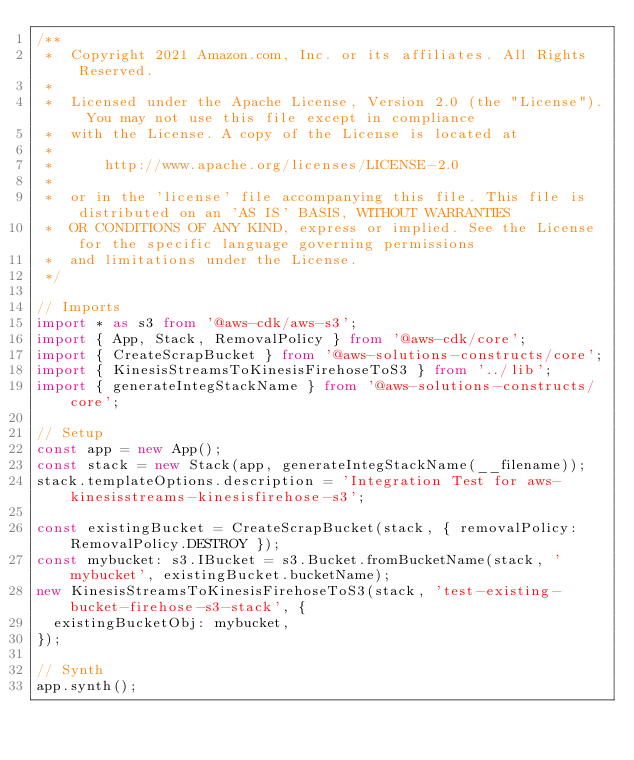<code> <loc_0><loc_0><loc_500><loc_500><_TypeScript_>/**
 *  Copyright 2021 Amazon.com, Inc. or its affiliates. All Rights Reserved.
 *
 *  Licensed under the Apache License, Version 2.0 (the "License"). You may not use this file except in compliance
 *  with the License. A copy of the License is located at
 *
 *      http://www.apache.org/licenses/LICENSE-2.0
 *
 *  or in the 'license' file accompanying this file. This file is distributed on an 'AS IS' BASIS, WITHOUT WARRANTIES
 *  OR CONDITIONS OF ANY KIND, express or implied. See the License for the specific language governing permissions
 *  and limitations under the License.
 */

// Imports
import * as s3 from '@aws-cdk/aws-s3';
import { App, Stack, RemovalPolicy } from '@aws-cdk/core';
import { CreateScrapBucket } from '@aws-solutions-constructs/core';
import { KinesisStreamsToKinesisFirehoseToS3 } from '../lib';
import { generateIntegStackName } from '@aws-solutions-constructs/core';

// Setup
const app = new App();
const stack = new Stack(app, generateIntegStackName(__filename));
stack.templateOptions.description = 'Integration Test for aws-kinesisstreams-kinesisfirehose-s3';

const existingBucket = CreateScrapBucket(stack, { removalPolicy: RemovalPolicy.DESTROY });
const mybucket: s3.IBucket = s3.Bucket.fromBucketName(stack, 'mybucket', existingBucket.bucketName);
new KinesisStreamsToKinesisFirehoseToS3(stack, 'test-existing-bucket-firehose-s3-stack', {
  existingBucketObj: mybucket,
});

// Synth
app.synth();
</code> 